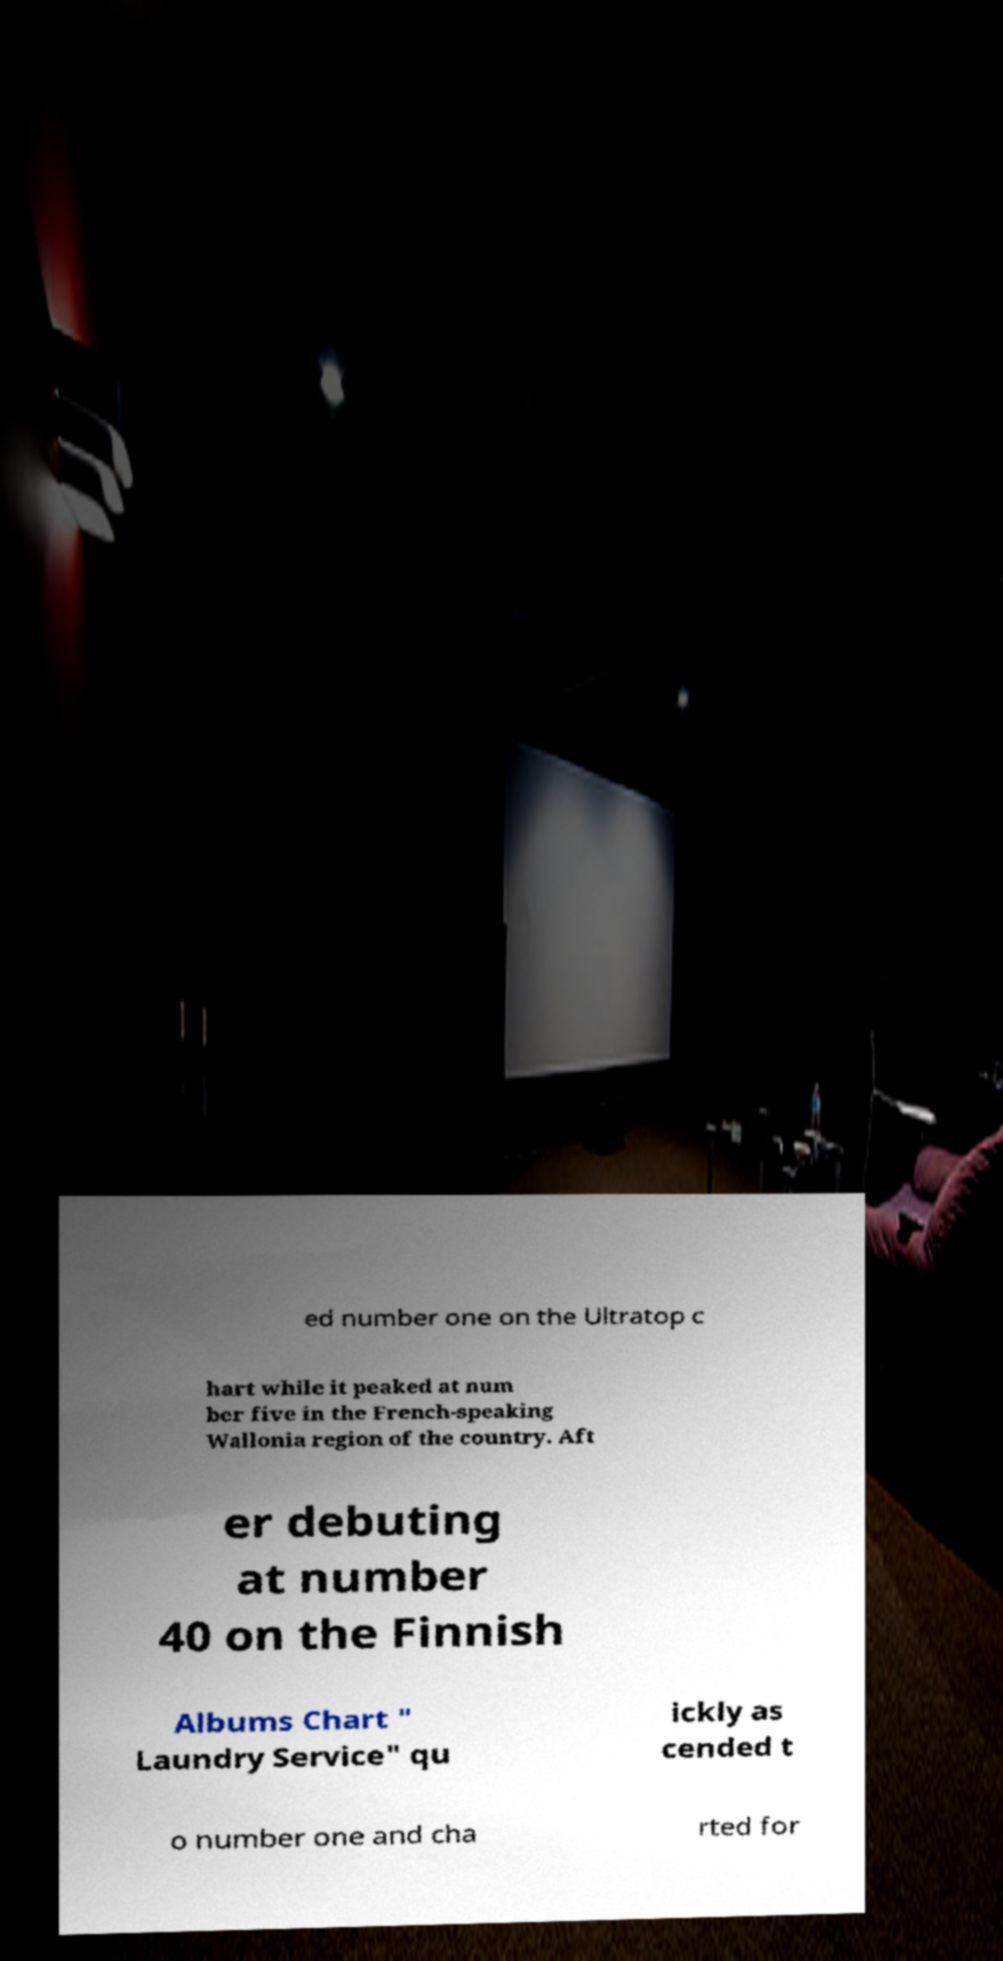Could you assist in decoding the text presented in this image and type it out clearly? ed number one on the Ultratop c hart while it peaked at num ber five in the French-speaking Wallonia region of the country. Aft er debuting at number 40 on the Finnish Albums Chart " Laundry Service" qu ickly as cended t o number one and cha rted for 